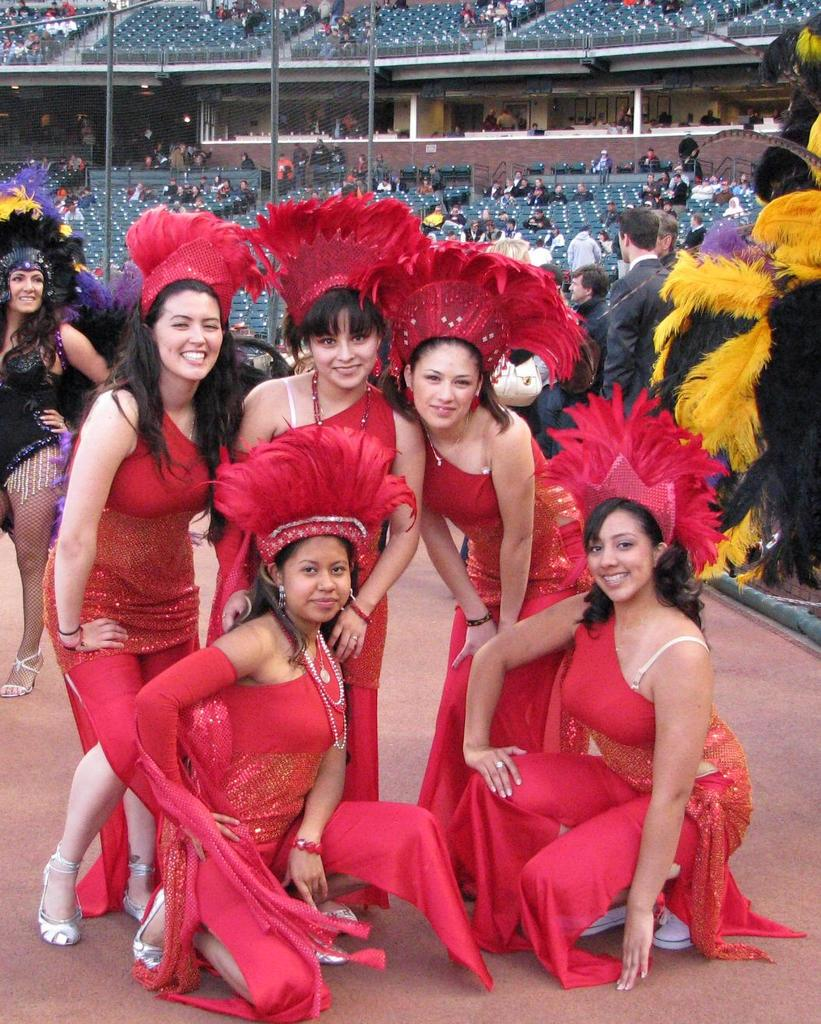What is the common feature among the women in the image? The women in the image are all wearing red dresses. What is the facial expression of the women in the image? The women are smiling in the image. What can be seen in the background of the image? In the background of the image, there are people, chairs, poles, and other objects. How many women are present in the image? The number of women in the image is not specified, but there is a group of women. What type of leather material can be seen on the women's legs in the image? There is no leather material visible on the women's legs in the image. What kind of kite is being flown by one of the women in the image? There is no kite present in the image. 